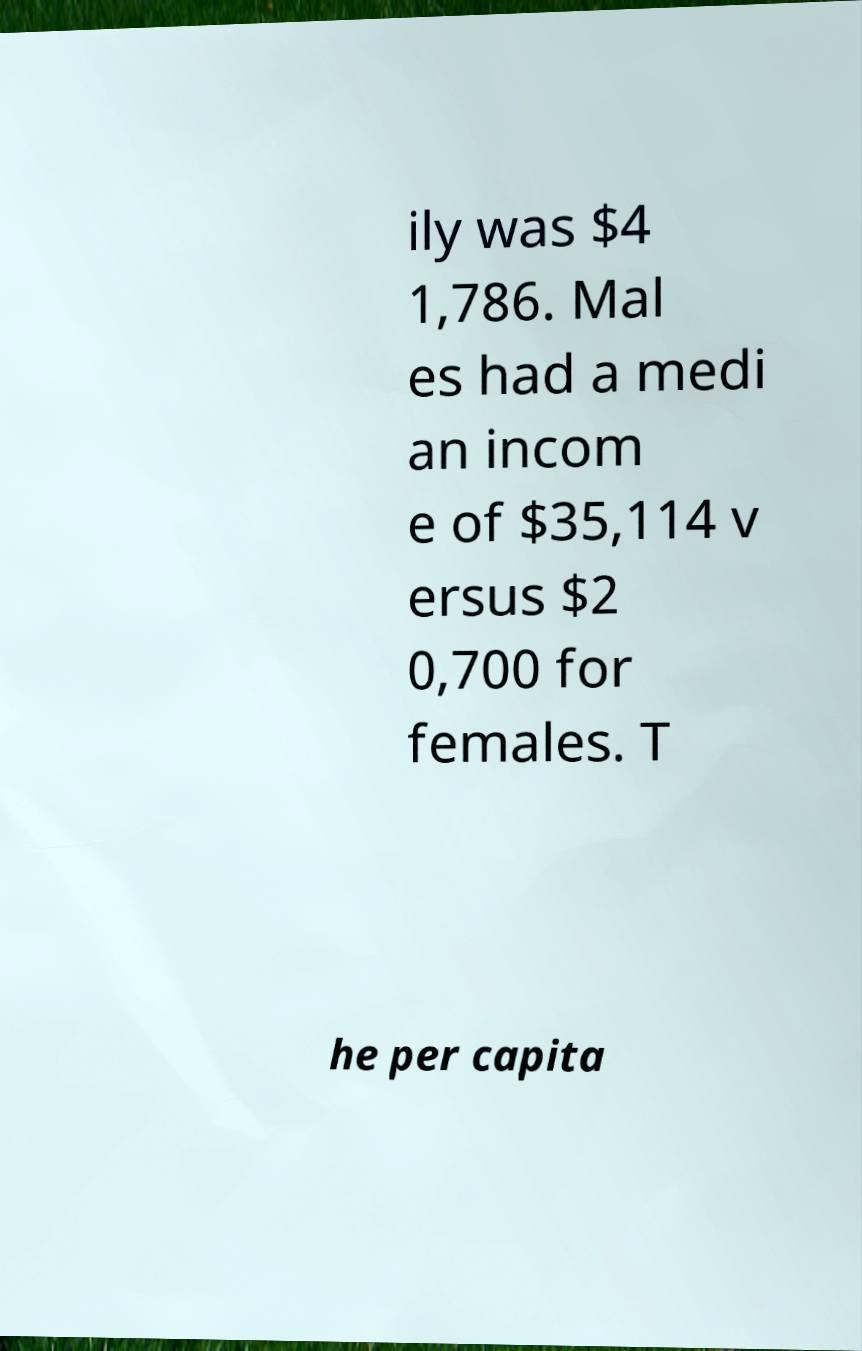Please identify and transcribe the text found in this image. ily was $4 1,786. Mal es had a medi an incom e of $35,114 v ersus $2 0,700 for females. T he per capita 